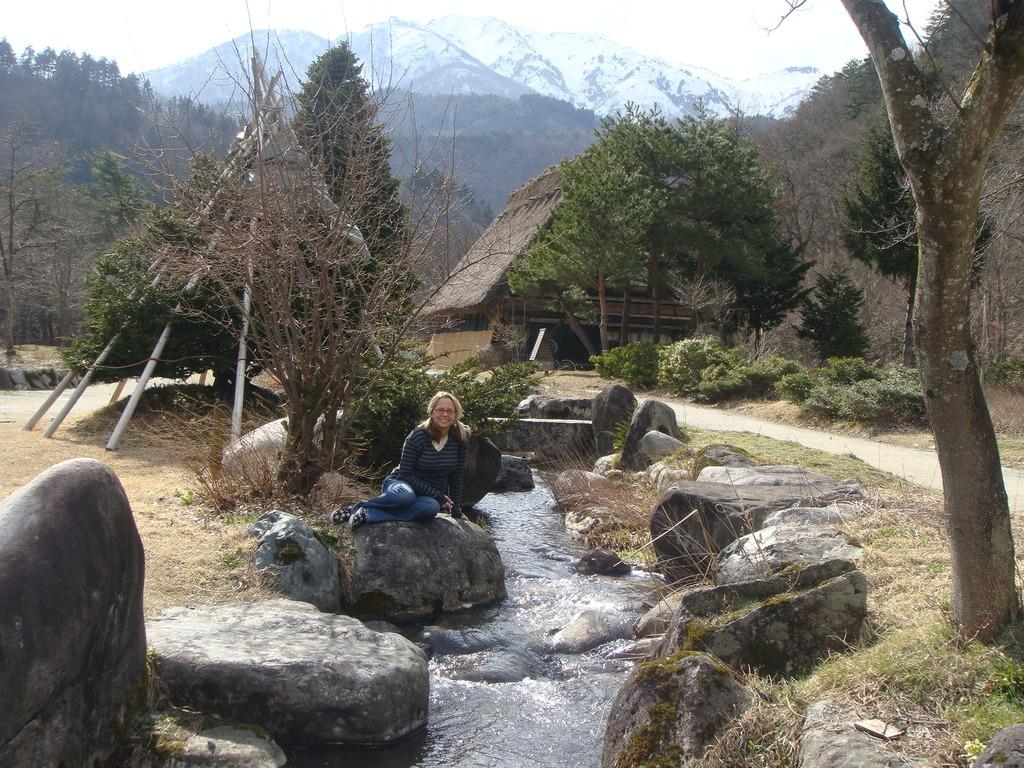What is the woman in the image doing? The woman is sitting on a rock in the image. What can be seen in the middle of the image? There is water flowing in the middle of the image. What is visible in the background of the image? There is a hut, mountains, and trees in the background of the image. What type of circle can be seen in the image? There is no circle present in the image. Can you spot a robin in the image? There is no robin present in the image. 